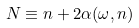<formula> <loc_0><loc_0><loc_500><loc_500>N \equiv n + 2 \alpha ( \omega , n )</formula> 